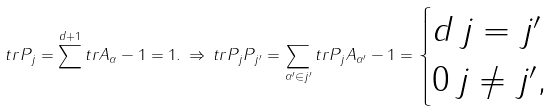Convert formula to latex. <formula><loc_0><loc_0><loc_500><loc_500>t r P _ { j } = \sum ^ { d + 1 } t r A _ { \alpha } - 1 = 1 . \, \Rightarrow \, t r P _ { j } P _ { j ^ { \prime } } = \sum _ { \alpha ^ { \prime } \in j ^ { \prime } } t r P _ { j } A _ { \alpha ^ { \prime } } - 1 = \begin{cases} d \, j = j ^ { \prime } \\ 0 \, j \ne j ^ { \prime } , \end{cases}</formula> 